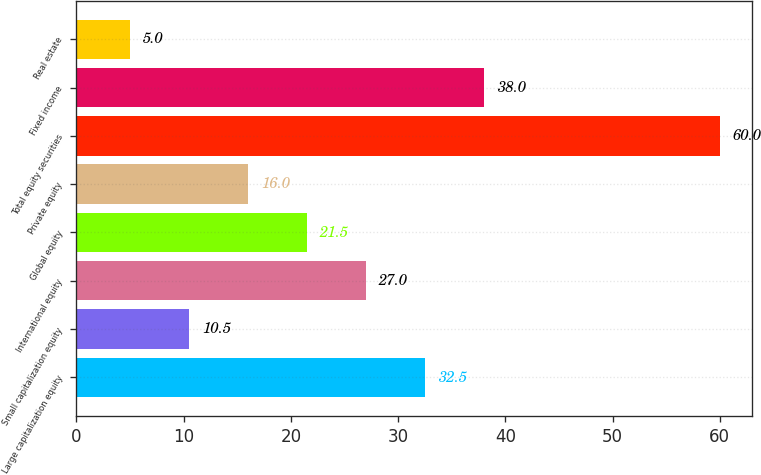<chart> <loc_0><loc_0><loc_500><loc_500><bar_chart><fcel>Large capitalization equity<fcel>Small capitalization equity<fcel>International equity<fcel>Global equity<fcel>Private equity<fcel>Total equity securities<fcel>Fixed income<fcel>Real estate<nl><fcel>32.5<fcel>10.5<fcel>27<fcel>21.5<fcel>16<fcel>60<fcel>38<fcel>5<nl></chart> 